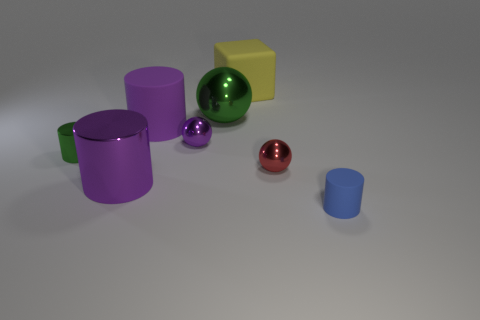Subtract all large metallic spheres. How many spheres are left? 2 Add 1 purple metal spheres. How many objects exist? 9 Subtract all red balls. How many balls are left? 2 Subtract 3 spheres. How many spheres are left? 0 Subtract all purple cylinders. How many purple spheres are left? 1 Subtract all tiny red balls. Subtract all big yellow matte blocks. How many objects are left? 6 Add 1 green spheres. How many green spheres are left? 2 Add 3 small shiny spheres. How many small shiny spheres exist? 5 Subtract 0 red cylinders. How many objects are left? 8 Subtract all blocks. How many objects are left? 7 